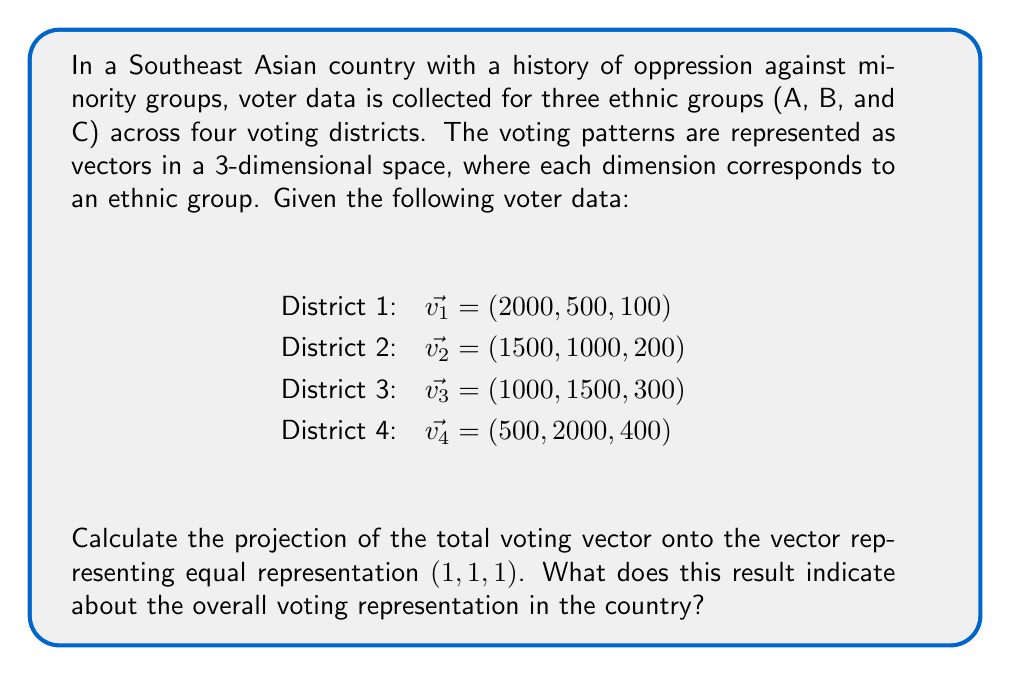Solve this math problem. Let's approach this step-by-step:

1) First, we need to calculate the total voting vector $\vec{v_{total}}$ by summing all district vectors:

   $\vec{v_{total}} = \vec{v_1} + \vec{v_2} + \vec{v_3} + \vec{v_4}$
   $= (2000, 500, 100) + (1500, 1000, 200) + (1000, 1500, 300) + (500, 2000, 400)$
   $= (5000, 5000, 1000)$

2) Let $\vec{u} = (1, 1, 1)$ be the vector representing equal representation.

3) The projection of $\vec{v_{total}}$ onto $\vec{u}$ is given by the formula:

   $proj_{\vec{u}}\vec{v_{total}} = \frac{\vec{v_{total}} \cdot \vec{u}}{\|\vec{u}\|^2} \vec{u}$

4) Calculate the dot product $\vec{v_{total}} \cdot \vec{u}$:
   
   $\vec{v_{total}} \cdot \vec{u} = 5000(1) + 5000(1) + 1000(1) = 11000$

5) Calculate $\|\vec{u}\|^2$:
   
   $\|\vec{u}\|^2 = 1^2 + 1^2 + 1^2 = 3$

6) Now we can calculate the projection:

   $proj_{\vec{u}}\vec{v_{total}} = \frac{11000}{3} (1, 1, 1) = (\frac{11000}{3}, \frac{11000}{3}, \frac{11000}{3})$

7) This result indicates that in a perfectly equal representation, each ethnic group would have $\frac{11000}{3} \approx 3667$ voters.

8) Comparing this to the actual total votes for each group (5000, 5000, 1000), we can see that groups A and B are overrepresented, while group C is significantly underrepresented.
Answer: $(\frac{11000}{3}, \frac{11000}{3}, \frac{11000}{3})$, indicating significant underrepresentation of group C. 